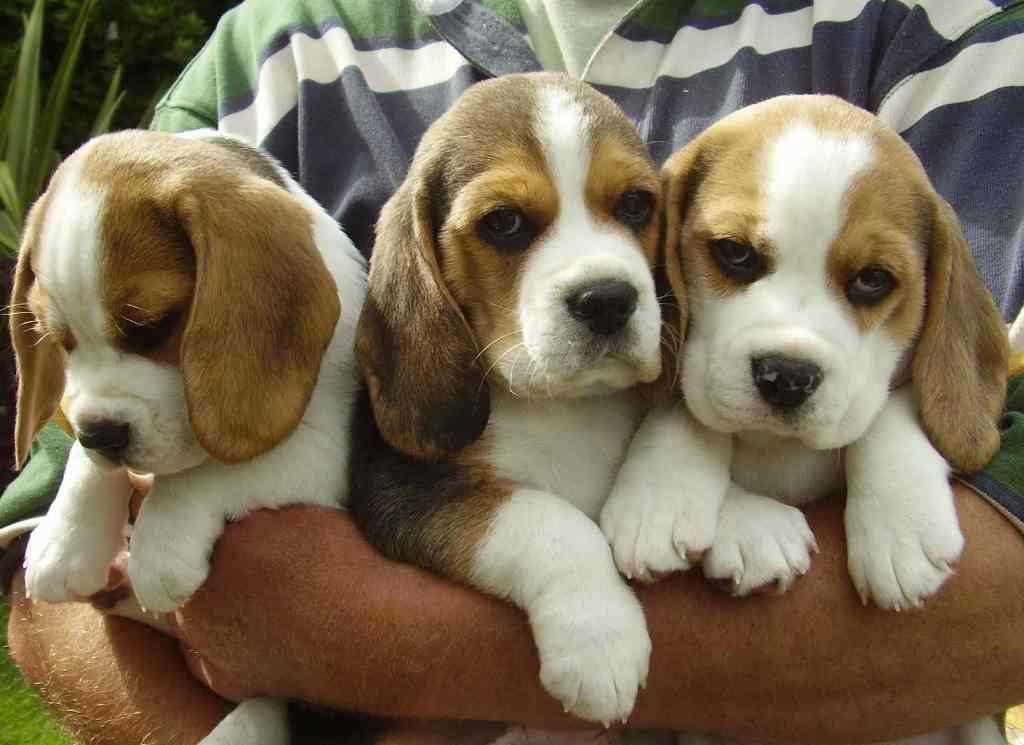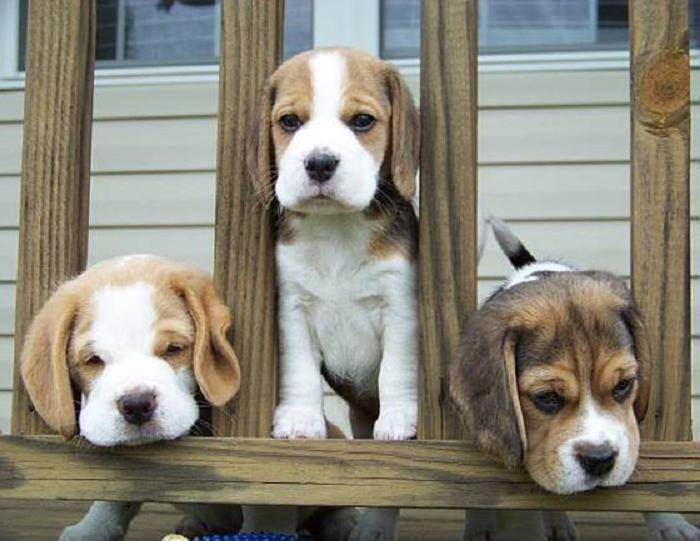The first image is the image on the left, the second image is the image on the right. For the images shown, is this caption "There are at most five dogs." true? Answer yes or no. No. The first image is the image on the left, the second image is the image on the right. Given the left and right images, does the statement "One of the images has exactly two dogs." hold true? Answer yes or no. No. 